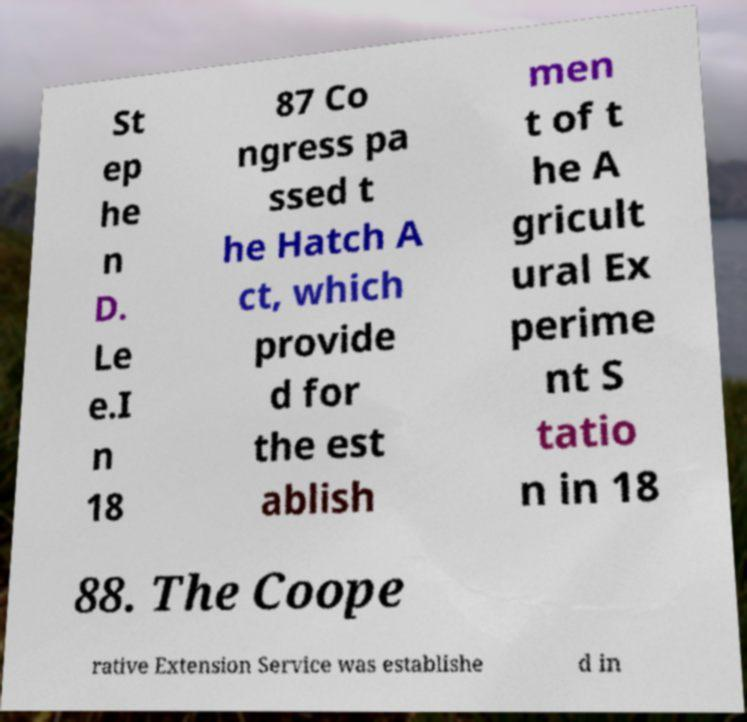Can you read and provide the text displayed in the image?This photo seems to have some interesting text. Can you extract and type it out for me? St ep he n D. Le e.I n 18 87 Co ngress pa ssed t he Hatch A ct, which provide d for the est ablish men t of t he A gricult ural Ex perime nt S tatio n in 18 88. The Coope rative Extension Service was establishe d in 